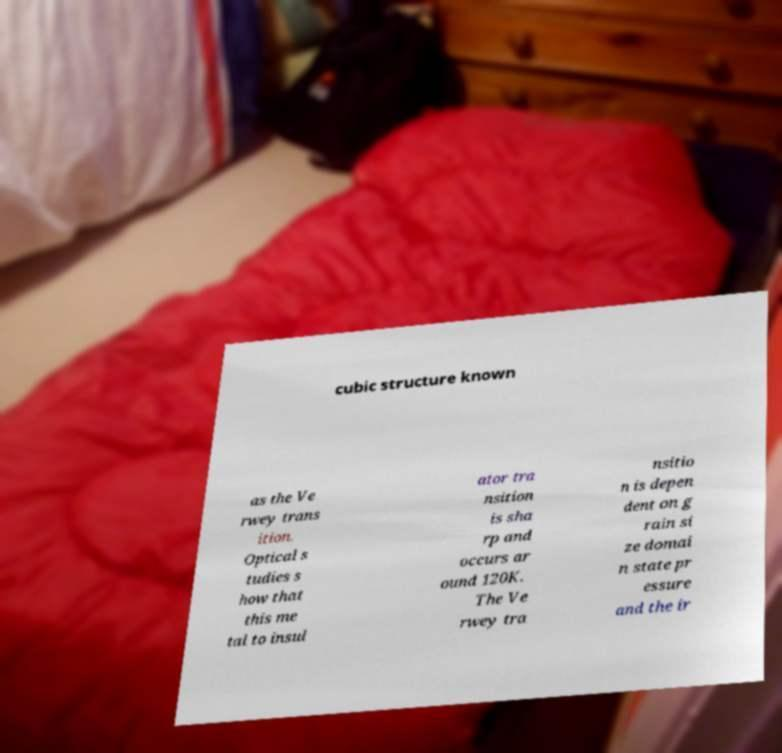What messages or text are displayed in this image? I need them in a readable, typed format. cubic structure known as the Ve rwey trans ition. Optical s tudies s how that this me tal to insul ator tra nsition is sha rp and occurs ar ound 120K. The Ve rwey tra nsitio n is depen dent on g rain si ze domai n state pr essure and the ir 